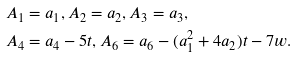Convert formula to latex. <formula><loc_0><loc_0><loc_500><loc_500>A _ { 1 } & = a _ { 1 } , A _ { 2 } = a _ { 2 } , A _ { 3 } = a _ { 3 } , \\ A _ { 4 } & = a _ { 4 } - 5 t , A _ { 6 } = a _ { 6 } - ( a _ { 1 } ^ { 2 } + 4 a _ { 2 } ) t - 7 w .</formula> 